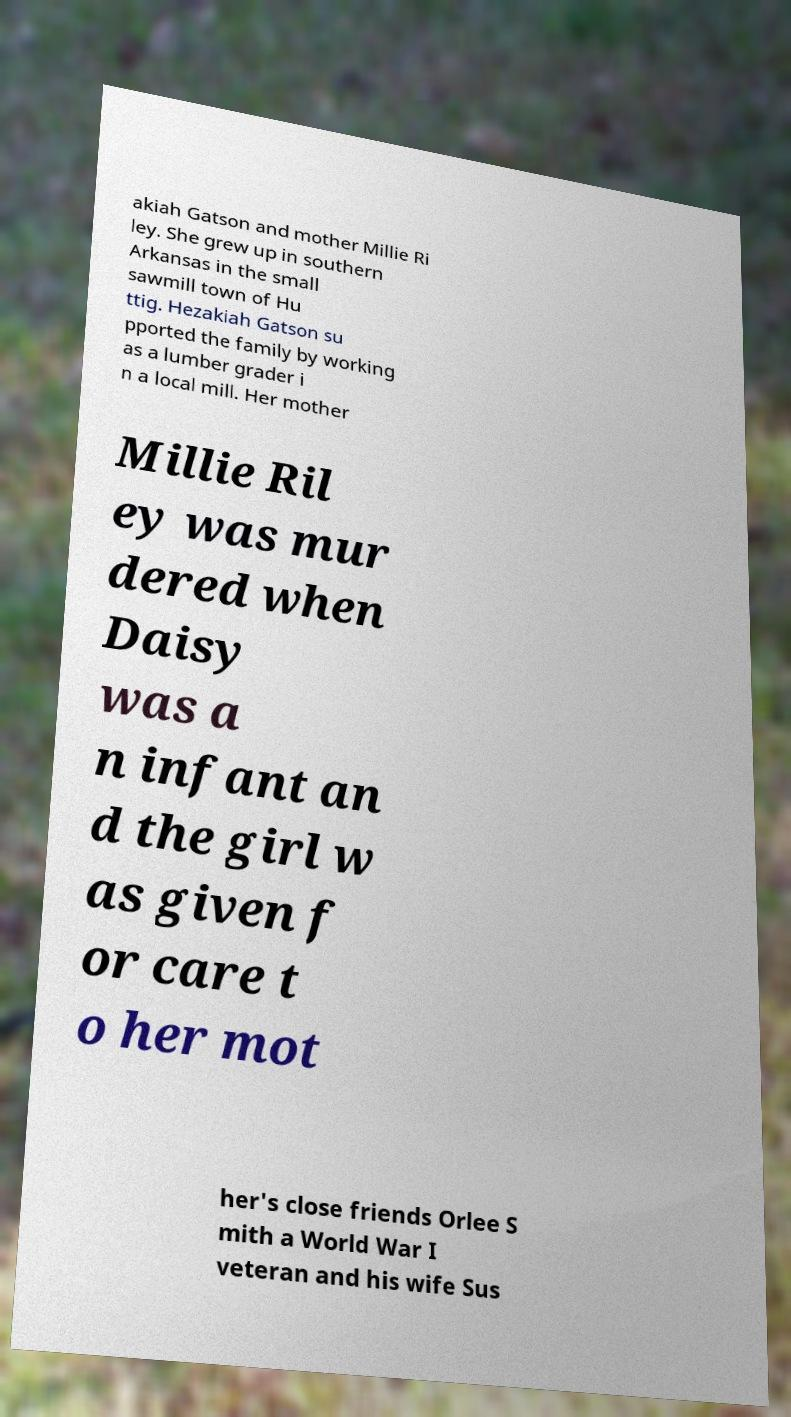What messages or text are displayed in this image? I need them in a readable, typed format. akiah Gatson and mother Millie Ri ley. She grew up in southern Arkansas in the small sawmill town of Hu ttig. Hezakiah Gatson su pported the family by working as a lumber grader i n a local mill. Her mother Millie Ril ey was mur dered when Daisy was a n infant an d the girl w as given f or care t o her mot her's close friends Orlee S mith a World War I veteran and his wife Sus 